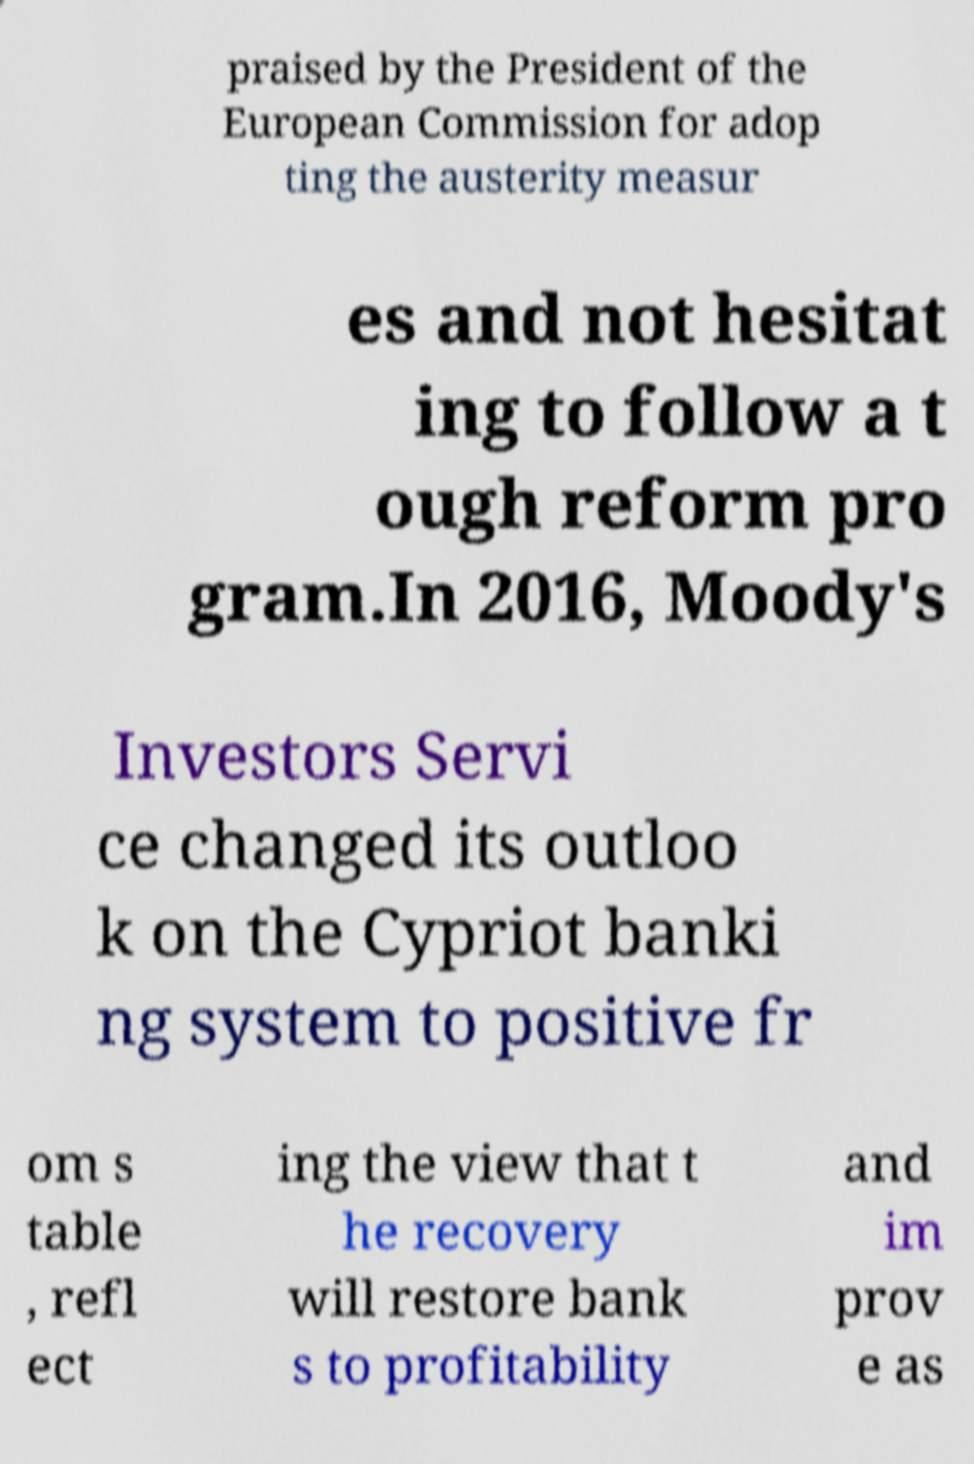Can you accurately transcribe the text from the provided image for me? praised by the President of the European Commission for adop ting the austerity measur es and not hesitat ing to follow a t ough reform pro gram.In 2016, Moody's Investors Servi ce changed its outloo k on the Cypriot banki ng system to positive fr om s table , refl ect ing the view that t he recovery will restore bank s to profitability and im prov e as 